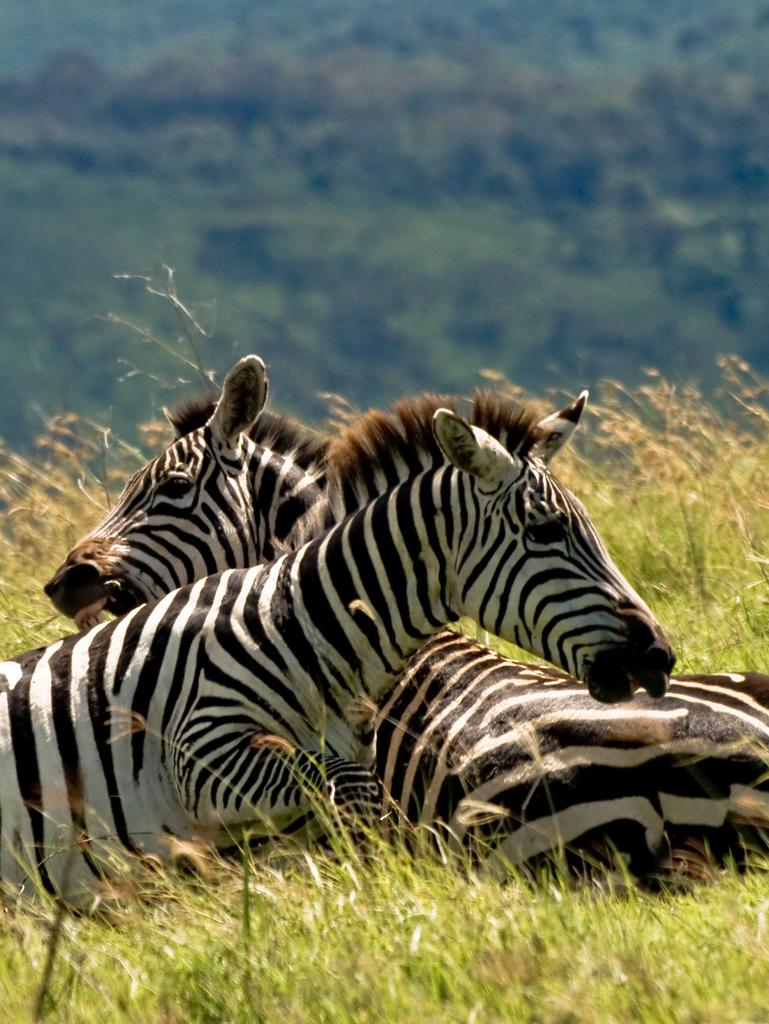What types of living organisms can be seen in the image? There are two animals in the image. What type of vegetation is visible in the image? There is grass visible in the image. What can be seen in the background of the image? There is a group of trees in the background of the image. What type of lettuce is being served to the governor in the image? There is no lettuce or governor present in the image. 